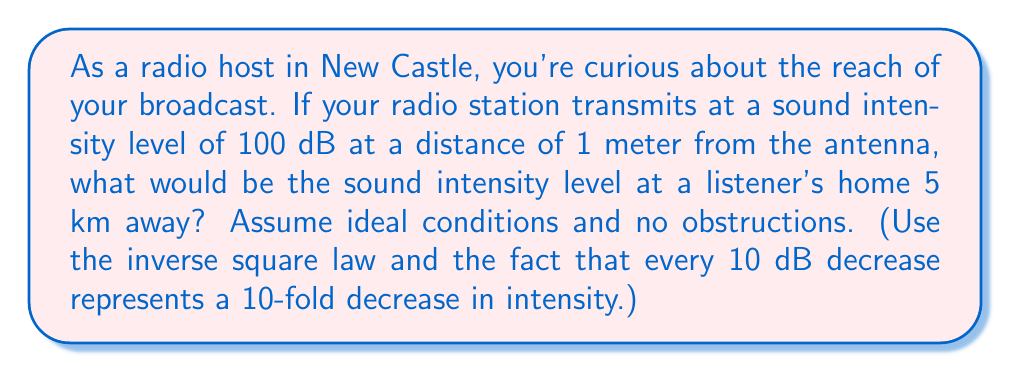Show me your answer to this math problem. Let's approach this step-by-step:

1) The inverse square law states that the intensity of sound decreases proportionally to the square of the distance from the source. We can express this as:

   $$\frac{I_1}{I_2} = \frac{r_2^2}{r_1^2}$$

   where $I$ is intensity and $r$ is distance.

2) We're given the initial distance $r_1 = 1$ m and the final distance $r_2 = 5$ km = 5000 m.

3) The ratio of intensities is:

   $$\frac{I_1}{I_2} = \frac{5000^2}{1^2} = 25,000,000$$

4) This means the intensity at 5 km is $\frac{1}{25,000,000}$ of the intensity at 1 m.

5) In terms of decibels, we know that every 10 dB decrease represents a 10-fold decrease in intensity. So we need to find how many times we need to divide by 10 to get 25,000,000.

6) We can express this mathematically as:

   $$10^x = 25,000,000$$

7) Taking the log of both sides:

   $$x = \log_{10}(25,000,000) \approx 7.398$$

8) This means the sound level decreases by approximately 73.98 dB.

9) The initial sound level was 100 dB, so the final sound level is:

   $$100 - 73.98 = 26.02\text{ dB}$$
Answer: 26.02 dB 